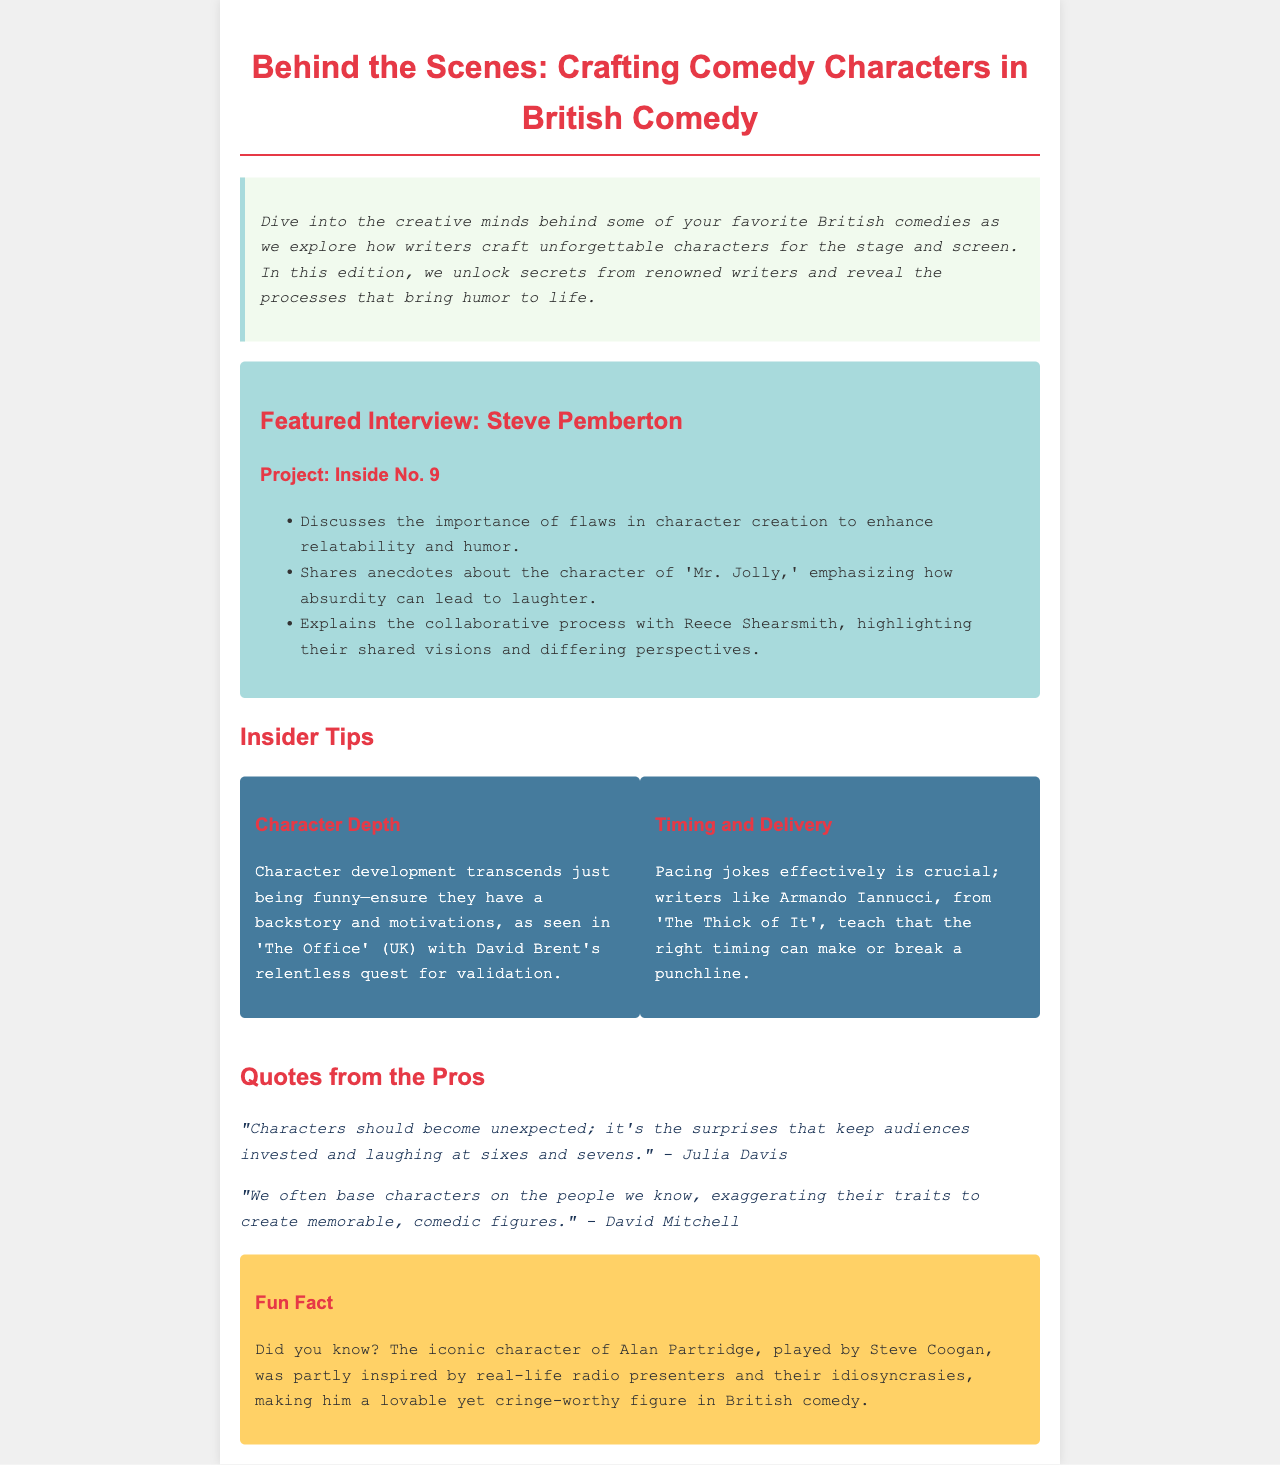What is the title of the newsletter? The title is presented at the top of the document and summarizes the main focus of the content.
Answer: Behind the Scenes: Crafting Comedy Characters in British Comedy Who is the featured interview with? The document includes a section specifically highlighting an interview with a notable figure in British comedy.
Answer: Steve Pemberton What television project is discussed in the interview? The interview section mentions a specific project related to the featured writer to provide context.
Answer: Inside No. 9 What is emphasized as important in character creation? This information is provided in the list detailing key discussion points from the interview.
Answer: Flaws Which character's absurdity is mentioned as a source of laughter? The document elaborates on a particular character that relates to humor in the interview.
Answer: Mr. Jolly What is one of the insider tips about character development? The tips section summarizes effective strategies that writers should employ in developing characters.
Answer: Ensure they have a backstory and motivations Who said that characters should become unexpected? The document cites a quote from a professional that reflects on character development strategies.
Answer: Julia Davis What does the fun fact relate to? This section provides an interesting piece of trivia associated with a specific character in British comedy.
Answer: Alan Partridge 